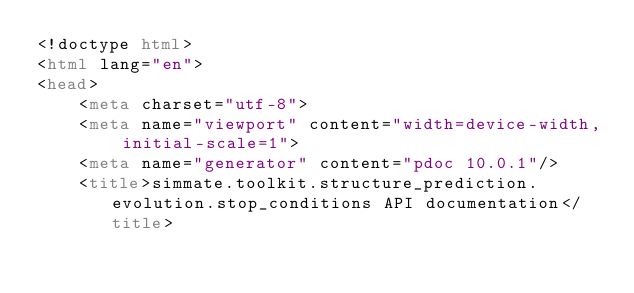Convert code to text. <code><loc_0><loc_0><loc_500><loc_500><_HTML_><!doctype html>
<html lang="en">
<head>
    <meta charset="utf-8">
    <meta name="viewport" content="width=device-width, initial-scale=1">
    <meta name="generator" content="pdoc 10.0.1"/>
    <title>simmate.toolkit.structure_prediction.evolution.stop_conditions API documentation</title>
</code> 